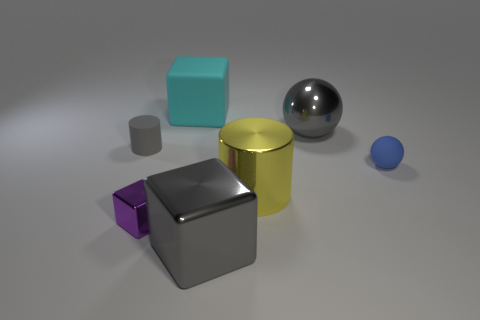Subtract all large blocks. How many blocks are left? 1 Add 1 small purple metallic cubes. How many objects exist? 8 Subtract all spheres. How many objects are left? 5 Subtract 2 spheres. How many spheres are left? 0 Subtract all cyan cubes. How many cubes are left? 2 Subtract all purple cubes. Subtract all brown balls. How many cubes are left? 2 Subtract all small gray objects. Subtract all big blue balls. How many objects are left? 6 Add 2 cyan cubes. How many cyan cubes are left? 3 Add 7 big metallic blocks. How many big metallic blocks exist? 8 Subtract 1 purple cubes. How many objects are left? 6 